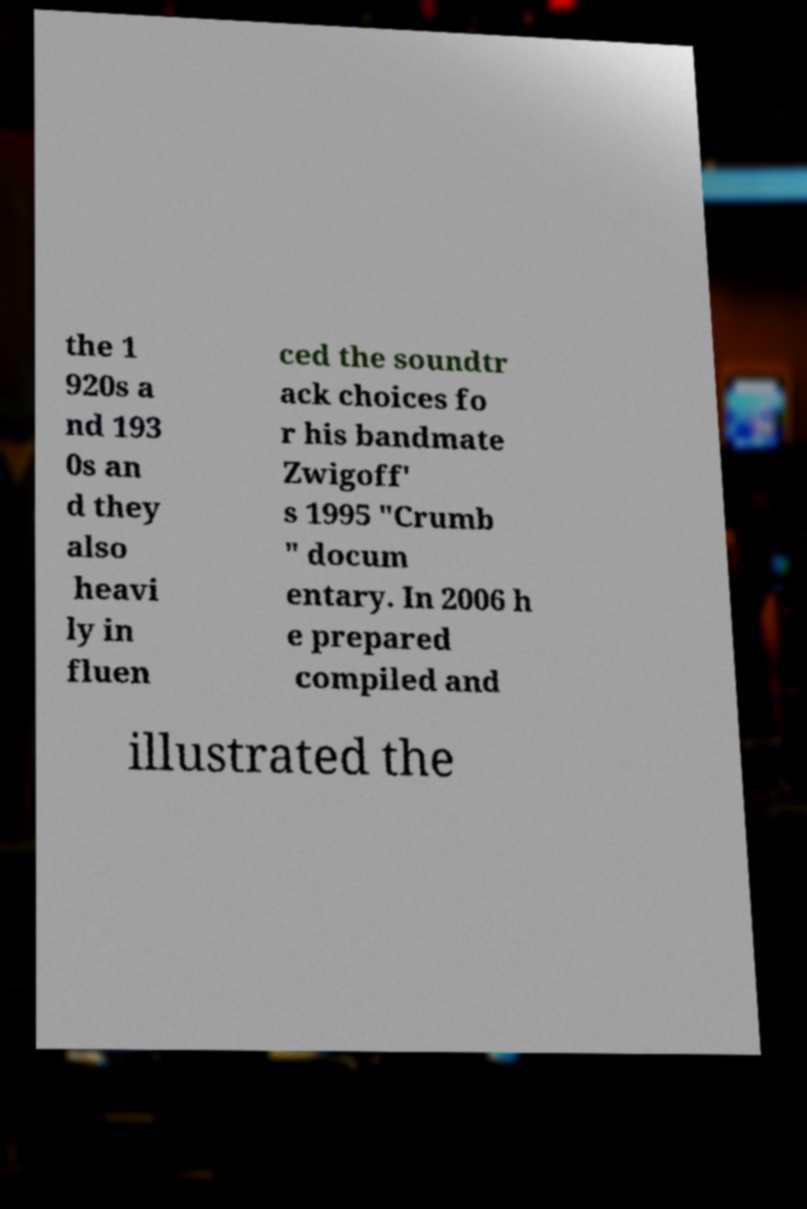Could you extract and type out the text from this image? the 1 920s a nd 193 0s an d they also heavi ly in fluen ced the soundtr ack choices fo r his bandmate Zwigoff' s 1995 "Crumb " docum entary. In 2006 h e prepared compiled and illustrated the 